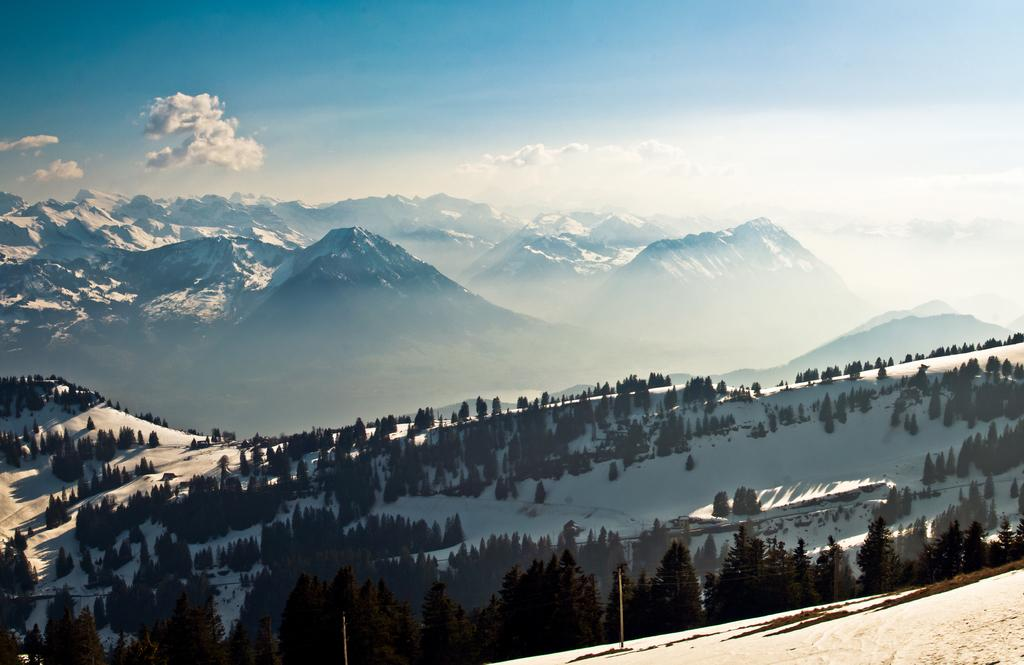What type of vegetation is present in the image? There are trees in the image. What is the condition of the ground beneath the trees? The trees are on a snow-covered floor. What geographical feature is visible in the center of the image? There are mountains in the center of the image. Can you see any corks floating in the snow in the image? There are no corks present in the image; it features trees on a snow-covered floor and mountains in the center. 